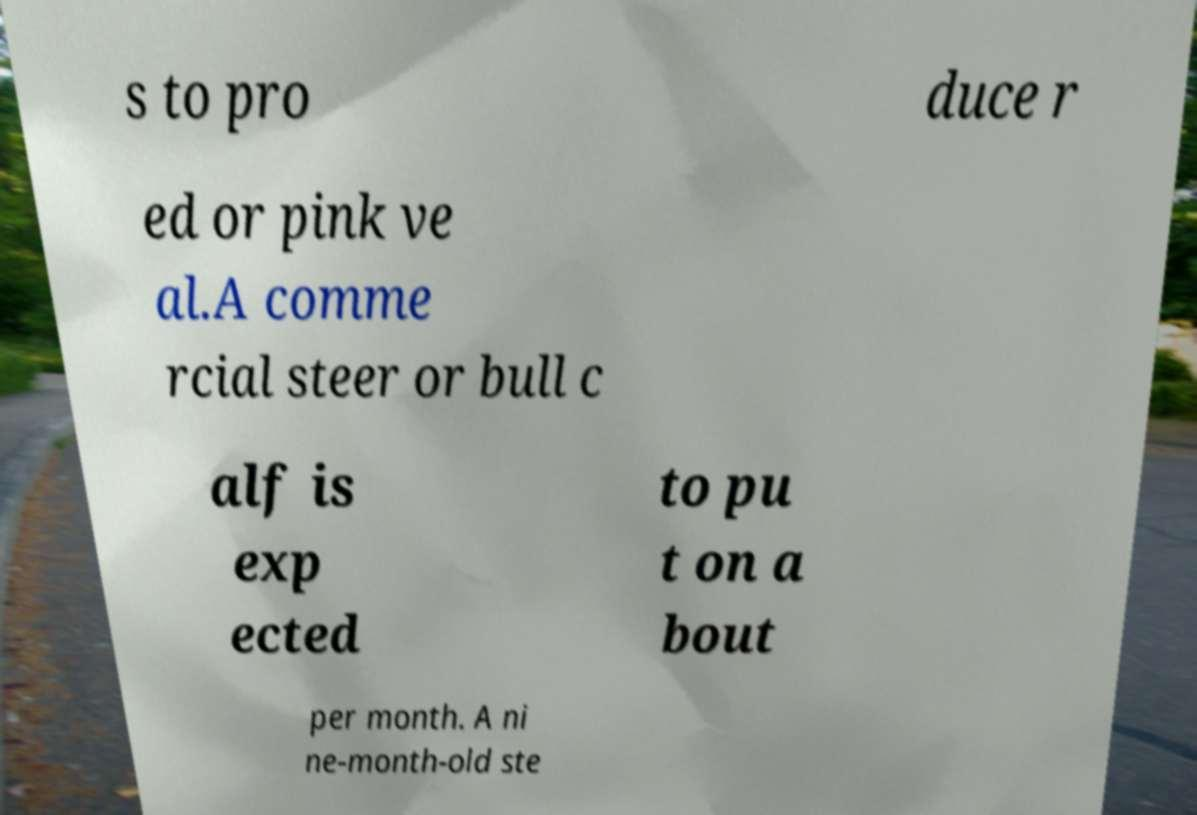I need the written content from this picture converted into text. Can you do that? s to pro duce r ed or pink ve al.A comme rcial steer or bull c alf is exp ected to pu t on a bout per month. A ni ne-month-old ste 